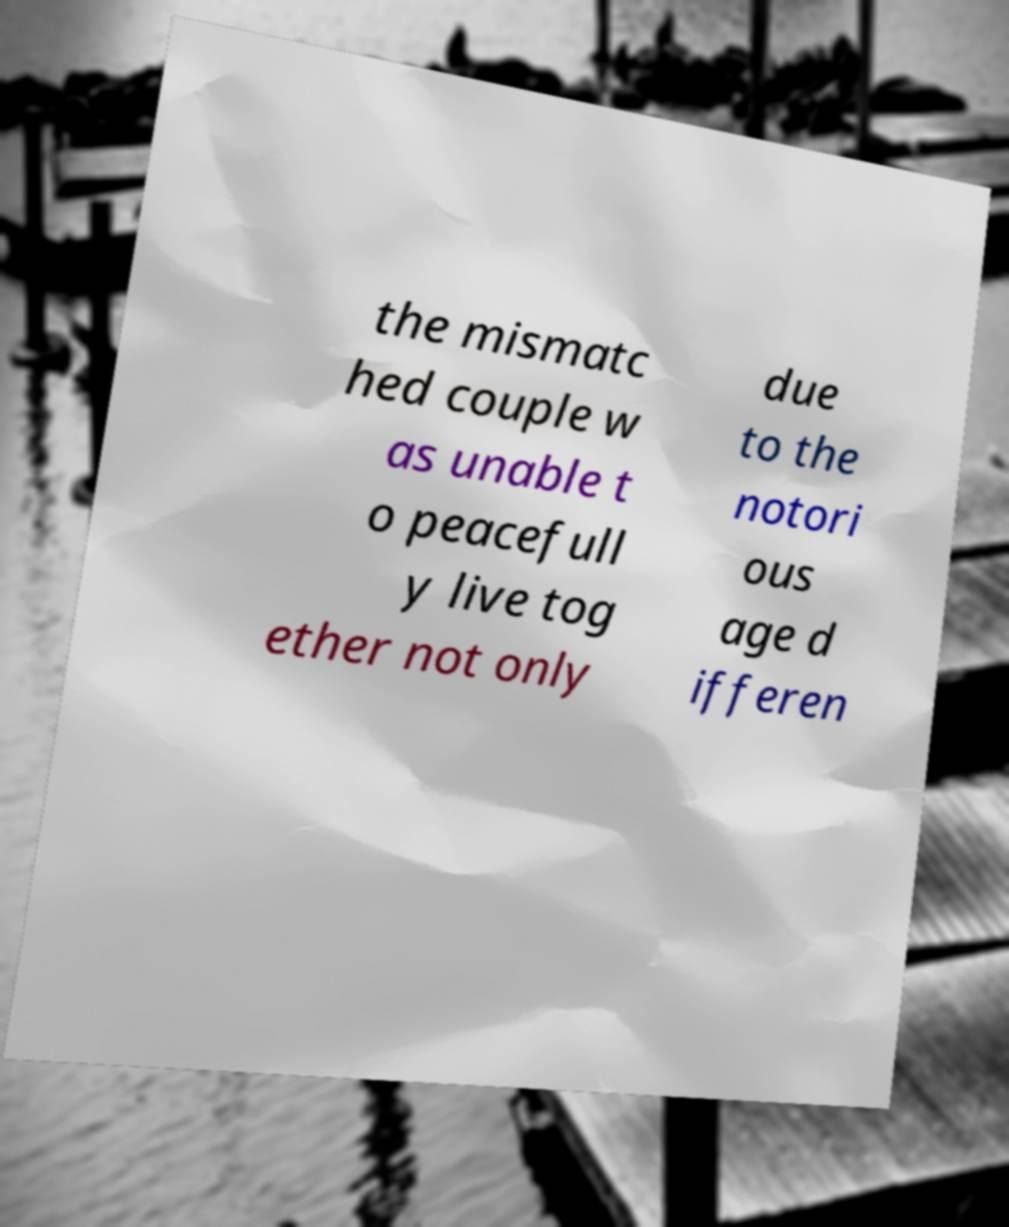For documentation purposes, I need the text within this image transcribed. Could you provide that? the mismatc hed couple w as unable t o peacefull y live tog ether not only due to the notori ous age d ifferen 